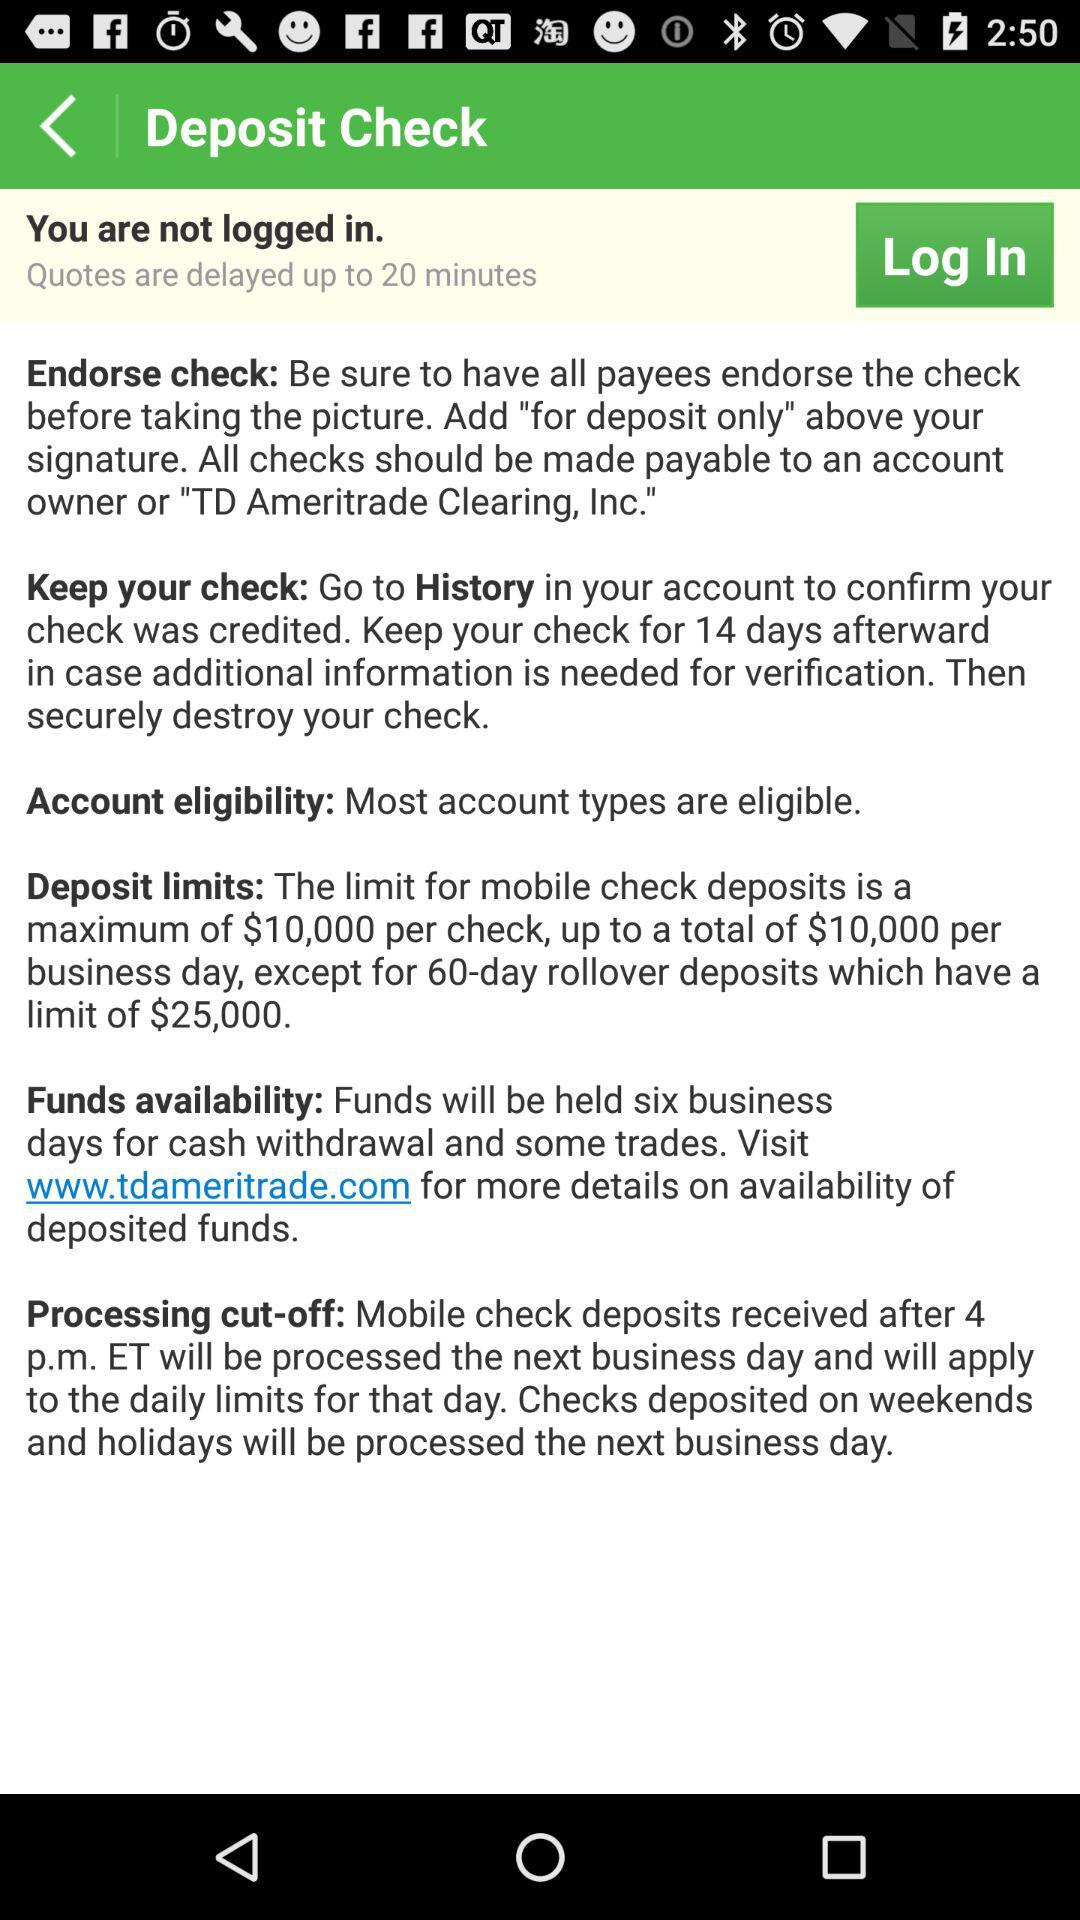What is the deposit limit for mobile check deposits? The deposit limit for mobile check deposits is a maximum of $10,000 per check. 